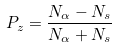<formula> <loc_0><loc_0><loc_500><loc_500>P _ { z } = \frac { N _ { \alpha } - N _ { s } } { N _ { \alpha } + N _ { s } }</formula> 